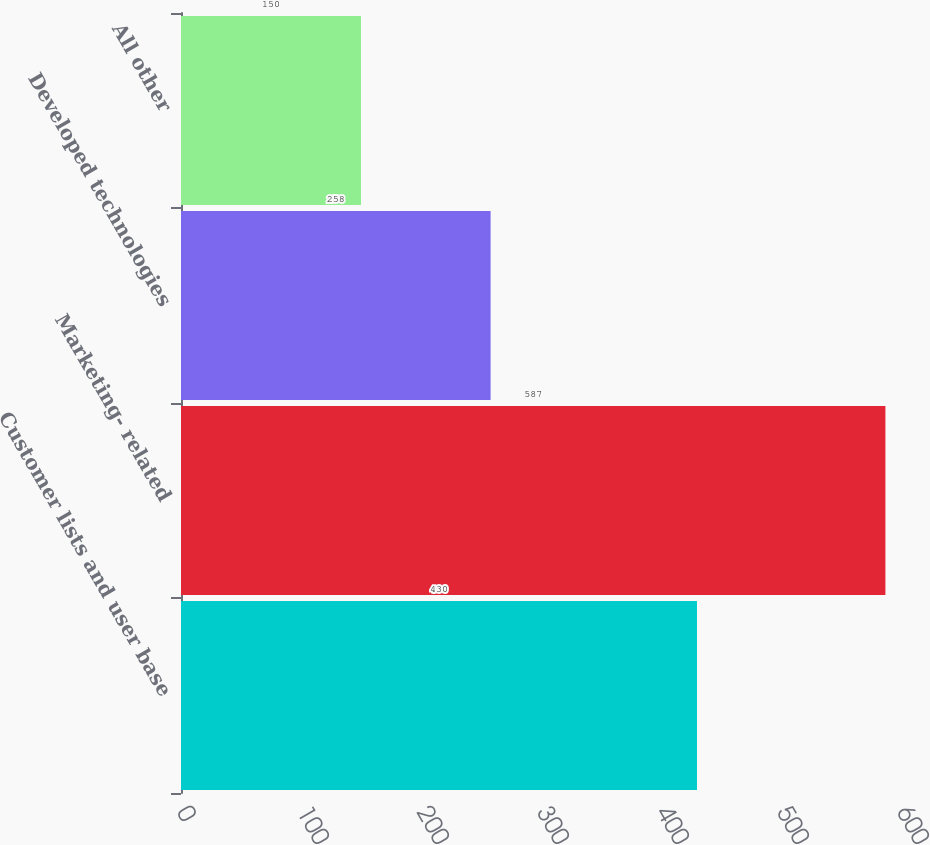Convert chart to OTSL. <chart><loc_0><loc_0><loc_500><loc_500><bar_chart><fcel>Customer lists and user base<fcel>Marketing- related<fcel>Developed technologies<fcel>All other<nl><fcel>430<fcel>587<fcel>258<fcel>150<nl></chart> 